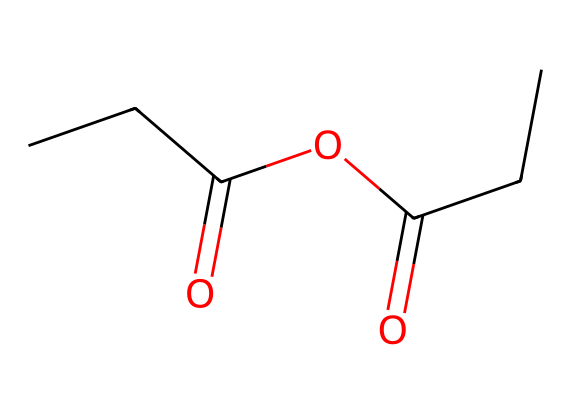How many carbon atoms are present in propionic anhydride? The SMILES representation shows "CCC" and "CC," which indicate there are a total of five carbon atoms in the structure.
Answer: five What is the main functional group in propionic anhydride? The structure has the anhydride linkage (two acyl groups connected by an oxygen atom), making the main functional group an anhydride.
Answer: anhydride What is the molecular formula of propionic anhydride? By counting the atoms represented in the SMILES, we find 5 carbon, 8 hydrogen, and 2 oxygen atoms, leading to the molecular formula C5H8O2.
Answer: C5H8O2 What type of reaction is typically used to synthesize propionic anhydride? Propionic anhydride is commonly synthesized through a reaction known as acylation, which involves connecting two acyl groups with an oxygen atom.
Answer: acylation What kind of chemical reactivity can anhydrides, including propionic anhydride, exhibit? Anhydrides, including propionic anhydride, are known for undergoing hydrolysis to form corresponding carboxylic acids, demonstrating their reactivity.
Answer: hydrolysis 